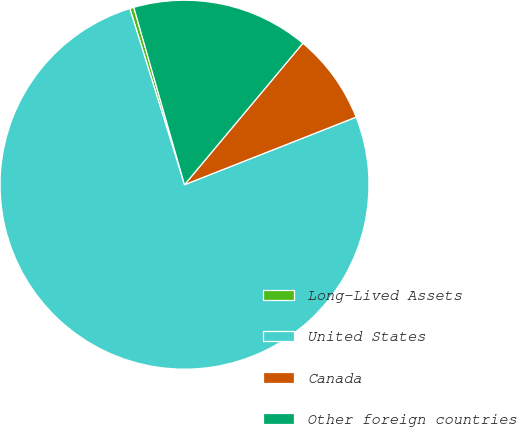Convert chart to OTSL. <chart><loc_0><loc_0><loc_500><loc_500><pie_chart><fcel>Long-Lived Assets<fcel>United States<fcel>Canada<fcel>Other foreign countries<nl><fcel>0.36%<fcel>76.18%<fcel>7.94%<fcel>15.52%<nl></chart> 